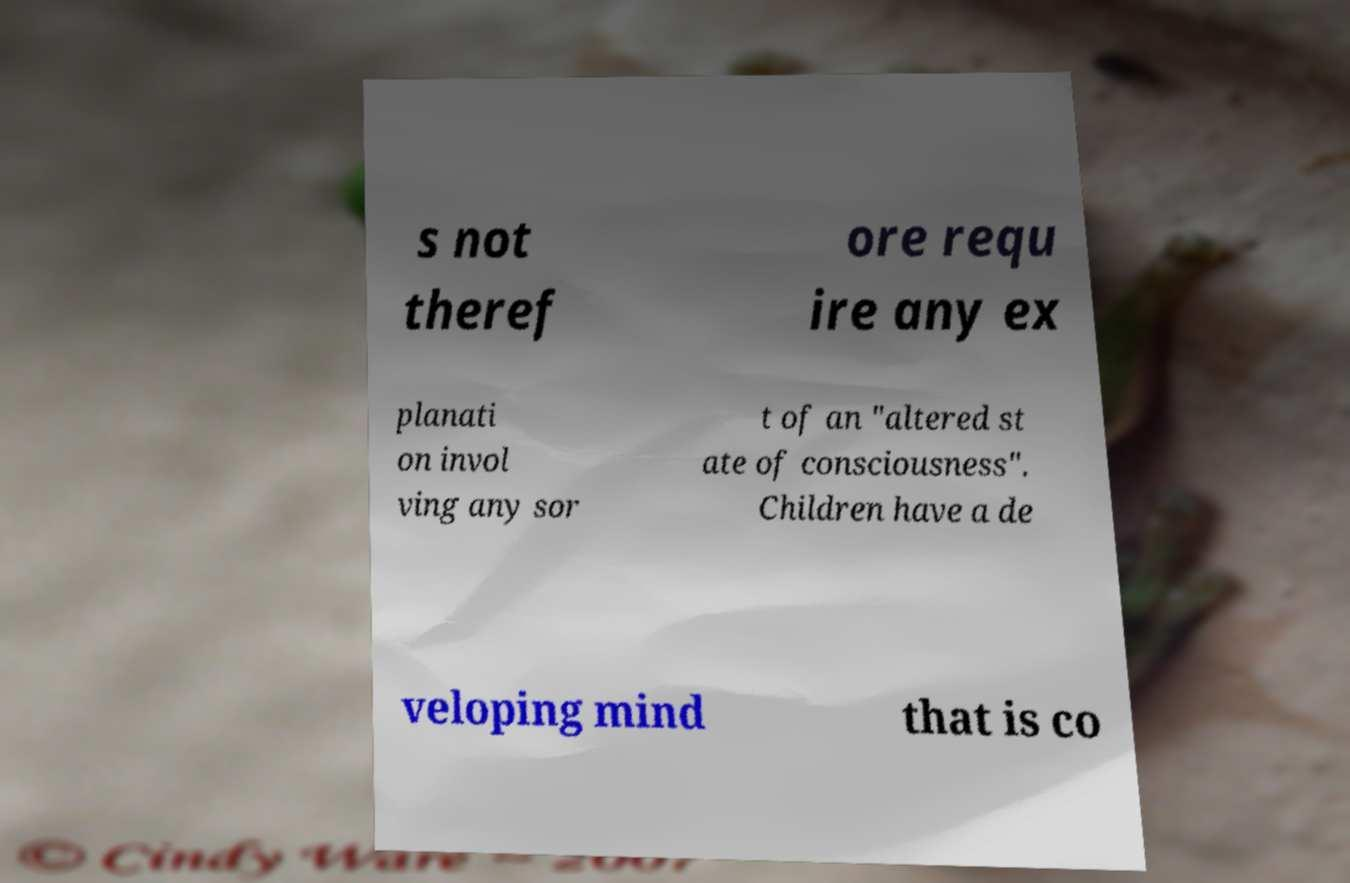Can you read and provide the text displayed in the image?This photo seems to have some interesting text. Can you extract and type it out for me? s not theref ore requ ire any ex planati on invol ving any sor t of an "altered st ate of consciousness". Children have a de veloping mind that is co 